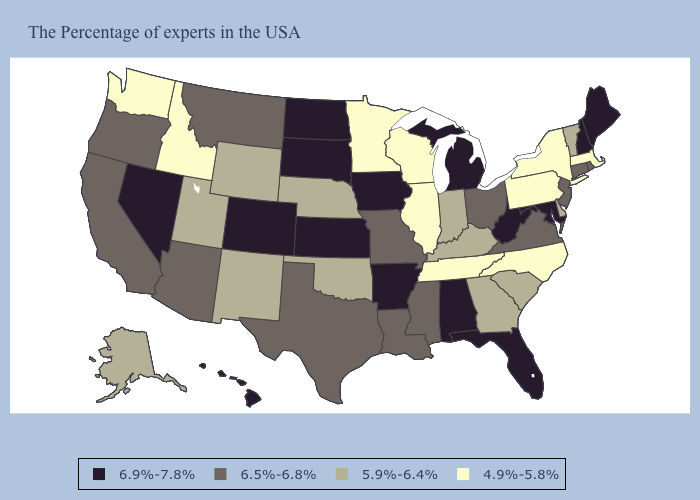Which states have the highest value in the USA?
Give a very brief answer. Maine, New Hampshire, Maryland, West Virginia, Florida, Michigan, Alabama, Arkansas, Iowa, Kansas, South Dakota, North Dakota, Colorado, Nevada, Hawaii. What is the value of Maine?
Give a very brief answer. 6.9%-7.8%. Among the states that border South Carolina , does North Carolina have the highest value?
Answer briefly. No. Does Kansas have the lowest value in the USA?
Concise answer only. No. How many symbols are there in the legend?
Answer briefly. 4. Does Texas have a lower value than Iowa?
Write a very short answer. Yes. What is the lowest value in the South?
Write a very short answer. 4.9%-5.8%. Does Ohio have a higher value than Montana?
Answer briefly. No. Does Virginia have the same value as Ohio?
Be succinct. Yes. Does Texas have the highest value in the USA?
Quick response, please. No. Is the legend a continuous bar?
Keep it brief. No. What is the lowest value in the USA?
Give a very brief answer. 4.9%-5.8%. How many symbols are there in the legend?
Give a very brief answer. 4. Does Tennessee have the highest value in the South?
Keep it brief. No. Name the states that have a value in the range 5.9%-6.4%?
Be succinct. Vermont, Delaware, South Carolina, Georgia, Kentucky, Indiana, Nebraska, Oklahoma, Wyoming, New Mexico, Utah, Alaska. 